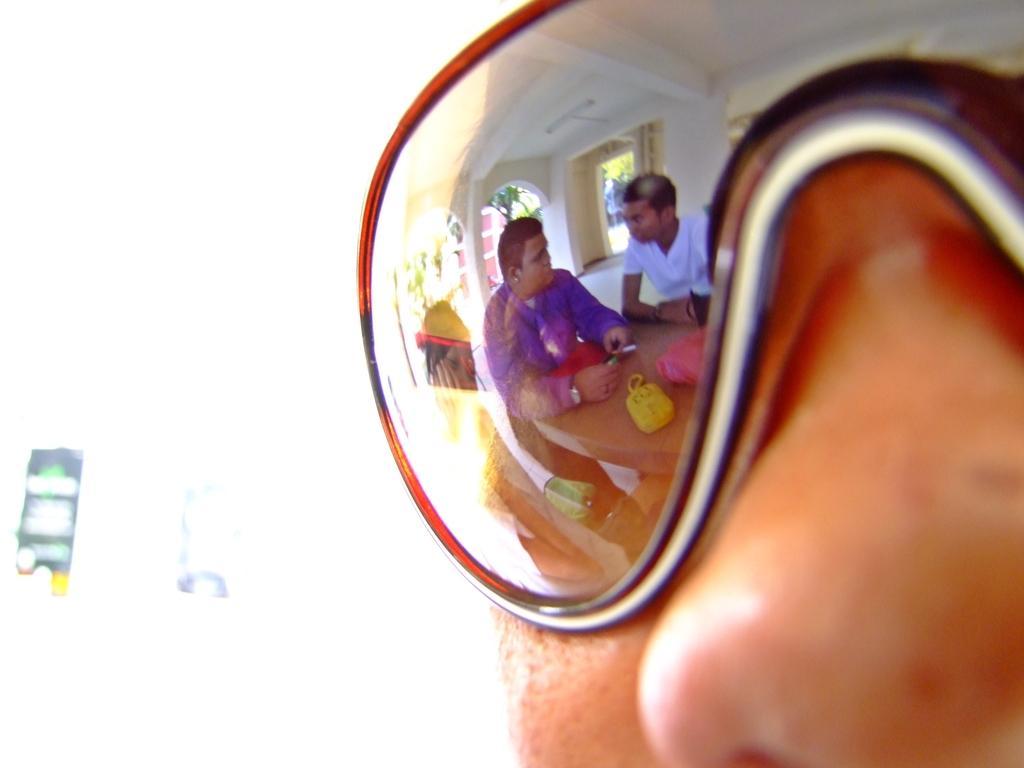Can you describe this image briefly? In this image there is a person wearing glasses on which we can see there is a reflection of people sitting around the table. 